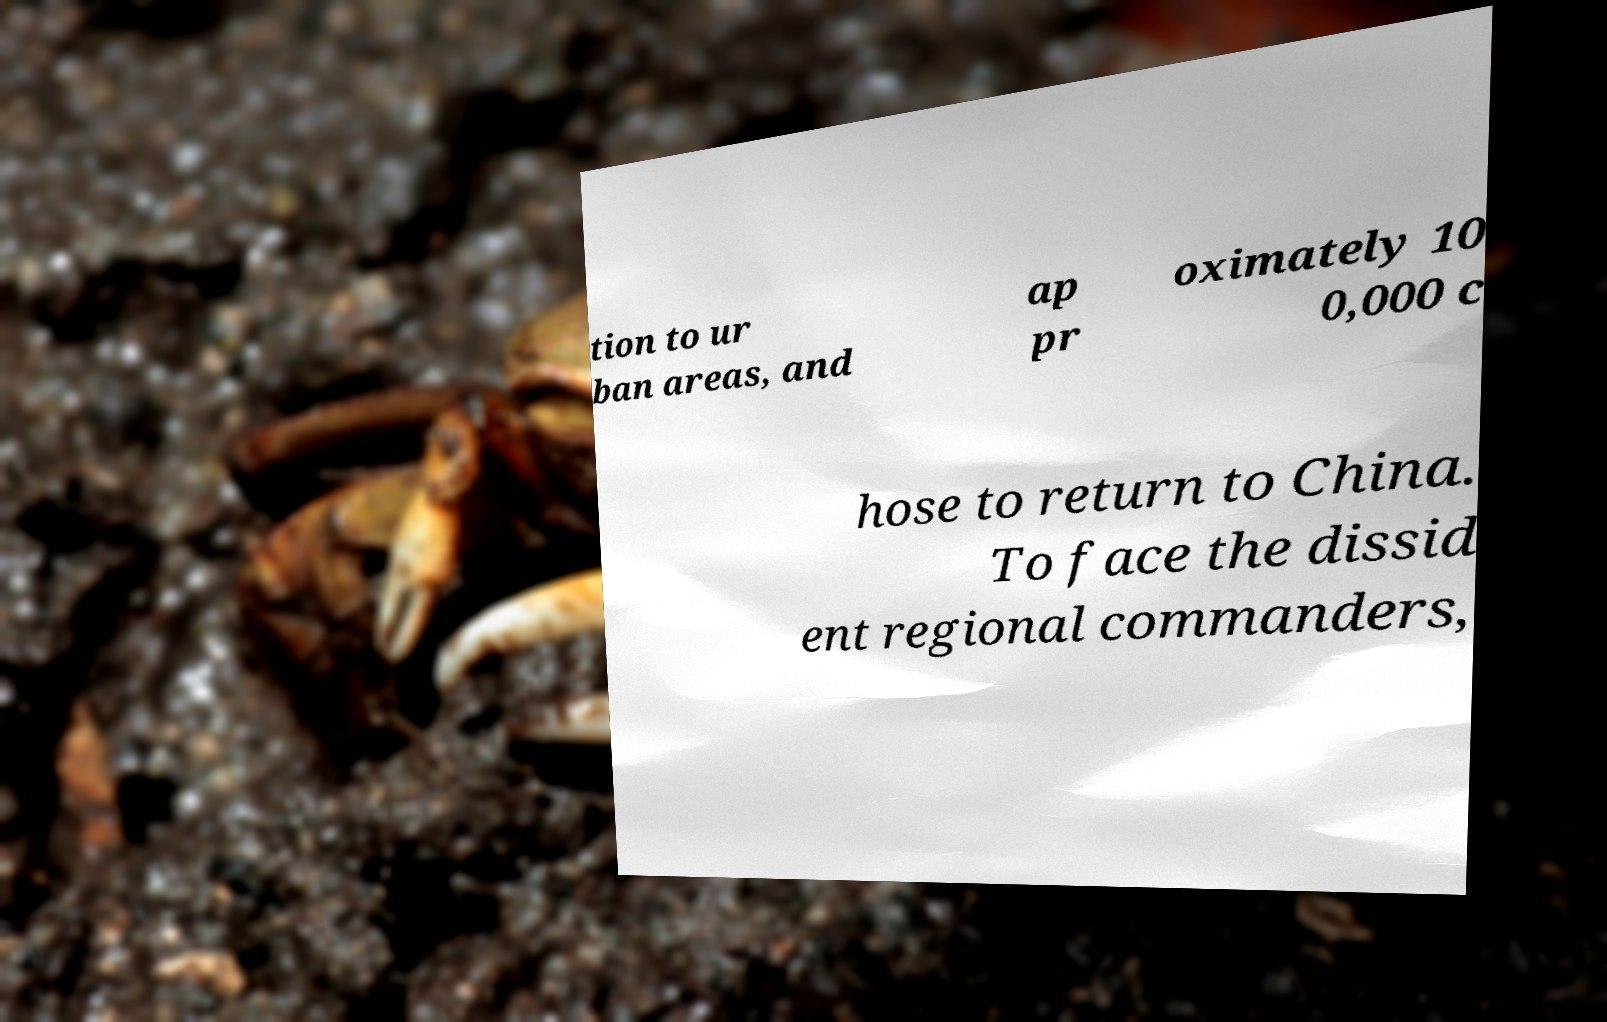There's text embedded in this image that I need extracted. Can you transcribe it verbatim? tion to ur ban areas, and ap pr oximately 10 0,000 c hose to return to China. To face the dissid ent regional commanders, 